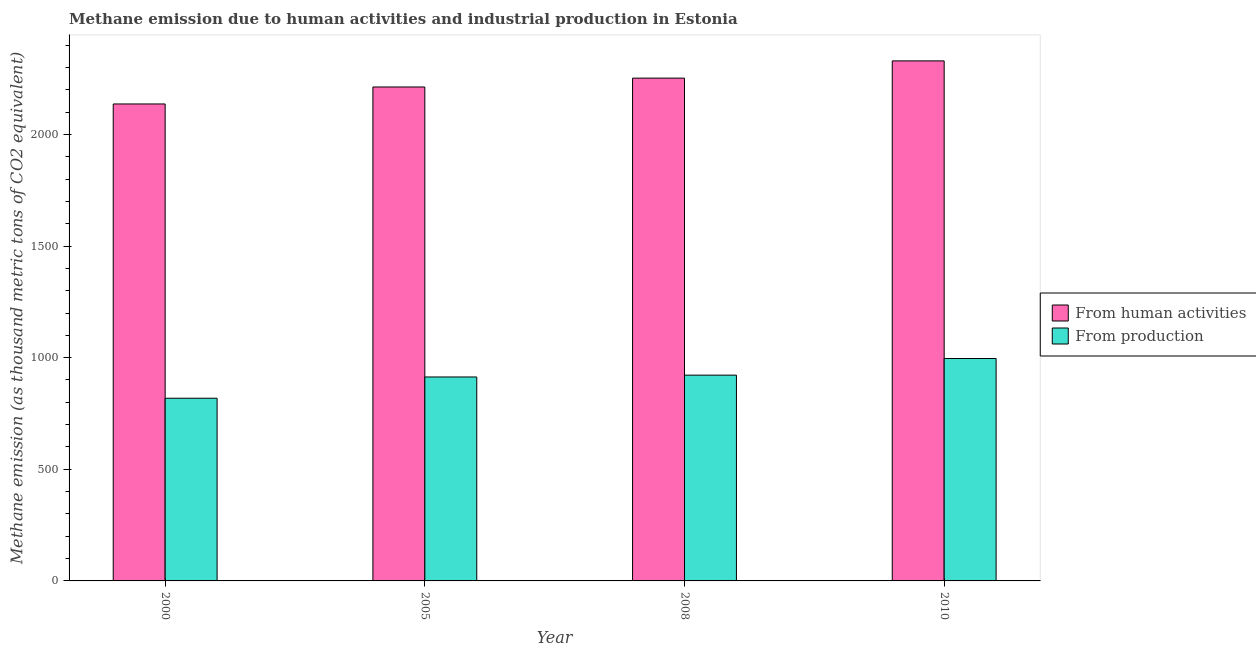How many different coloured bars are there?
Make the answer very short. 2. How many groups of bars are there?
Your response must be concise. 4. Are the number of bars per tick equal to the number of legend labels?
Provide a succinct answer. Yes. Are the number of bars on each tick of the X-axis equal?
Offer a terse response. Yes. How many bars are there on the 4th tick from the left?
Give a very brief answer. 2. How many bars are there on the 1st tick from the right?
Keep it short and to the point. 2. What is the label of the 4th group of bars from the left?
Make the answer very short. 2010. In how many cases, is the number of bars for a given year not equal to the number of legend labels?
Give a very brief answer. 0. What is the amount of emissions generated from industries in 2005?
Offer a terse response. 913.5. Across all years, what is the maximum amount of emissions generated from industries?
Offer a terse response. 996.2. Across all years, what is the minimum amount of emissions generated from industries?
Your response must be concise. 818.2. In which year was the amount of emissions generated from industries minimum?
Your answer should be compact. 2000. What is the total amount of emissions from human activities in the graph?
Ensure brevity in your answer.  8929.9. What is the difference between the amount of emissions generated from industries in 2008 and that in 2010?
Your answer should be compact. -74.5. What is the difference between the amount of emissions generated from industries in 2005 and the amount of emissions from human activities in 2008?
Offer a terse response. -8.2. What is the average amount of emissions from human activities per year?
Ensure brevity in your answer.  2232.48. In the year 2010, what is the difference between the amount of emissions from human activities and amount of emissions generated from industries?
Provide a succinct answer. 0. What is the ratio of the amount of emissions generated from industries in 2000 to that in 2010?
Make the answer very short. 0.82. Is the difference between the amount of emissions generated from industries in 2005 and 2010 greater than the difference between the amount of emissions from human activities in 2005 and 2010?
Your answer should be compact. No. What is the difference between the highest and the second highest amount of emissions from human activities?
Give a very brief answer. 77.3. What is the difference between the highest and the lowest amount of emissions generated from industries?
Make the answer very short. 178. Is the sum of the amount of emissions from human activities in 2000 and 2008 greater than the maximum amount of emissions generated from industries across all years?
Give a very brief answer. Yes. What does the 2nd bar from the left in 2005 represents?
Provide a succinct answer. From production. What does the 1st bar from the right in 2005 represents?
Provide a short and direct response. From production. How many years are there in the graph?
Your answer should be compact. 4. Does the graph contain any zero values?
Your answer should be compact. No. Does the graph contain grids?
Your response must be concise. No. What is the title of the graph?
Make the answer very short. Methane emission due to human activities and industrial production in Estonia. What is the label or title of the X-axis?
Your answer should be very brief. Year. What is the label or title of the Y-axis?
Provide a short and direct response. Methane emission (as thousand metric tons of CO2 equivalent). What is the Methane emission (as thousand metric tons of CO2 equivalent) of From human activities in 2000?
Your answer should be very brief. 2136.3. What is the Methane emission (as thousand metric tons of CO2 equivalent) in From production in 2000?
Provide a short and direct response. 818.2. What is the Methane emission (as thousand metric tons of CO2 equivalent) in From human activities in 2005?
Your answer should be very brief. 2212.3. What is the Methane emission (as thousand metric tons of CO2 equivalent) in From production in 2005?
Your response must be concise. 913.5. What is the Methane emission (as thousand metric tons of CO2 equivalent) in From human activities in 2008?
Your answer should be very brief. 2252. What is the Methane emission (as thousand metric tons of CO2 equivalent) of From production in 2008?
Your response must be concise. 921.7. What is the Methane emission (as thousand metric tons of CO2 equivalent) of From human activities in 2010?
Make the answer very short. 2329.3. What is the Methane emission (as thousand metric tons of CO2 equivalent) in From production in 2010?
Ensure brevity in your answer.  996.2. Across all years, what is the maximum Methane emission (as thousand metric tons of CO2 equivalent) of From human activities?
Make the answer very short. 2329.3. Across all years, what is the maximum Methane emission (as thousand metric tons of CO2 equivalent) in From production?
Your response must be concise. 996.2. Across all years, what is the minimum Methane emission (as thousand metric tons of CO2 equivalent) in From human activities?
Ensure brevity in your answer.  2136.3. Across all years, what is the minimum Methane emission (as thousand metric tons of CO2 equivalent) of From production?
Offer a very short reply. 818.2. What is the total Methane emission (as thousand metric tons of CO2 equivalent) in From human activities in the graph?
Ensure brevity in your answer.  8929.9. What is the total Methane emission (as thousand metric tons of CO2 equivalent) of From production in the graph?
Ensure brevity in your answer.  3649.6. What is the difference between the Methane emission (as thousand metric tons of CO2 equivalent) of From human activities in 2000 and that in 2005?
Ensure brevity in your answer.  -76. What is the difference between the Methane emission (as thousand metric tons of CO2 equivalent) in From production in 2000 and that in 2005?
Provide a succinct answer. -95.3. What is the difference between the Methane emission (as thousand metric tons of CO2 equivalent) of From human activities in 2000 and that in 2008?
Your answer should be compact. -115.7. What is the difference between the Methane emission (as thousand metric tons of CO2 equivalent) in From production in 2000 and that in 2008?
Give a very brief answer. -103.5. What is the difference between the Methane emission (as thousand metric tons of CO2 equivalent) in From human activities in 2000 and that in 2010?
Provide a short and direct response. -193. What is the difference between the Methane emission (as thousand metric tons of CO2 equivalent) of From production in 2000 and that in 2010?
Make the answer very short. -178. What is the difference between the Methane emission (as thousand metric tons of CO2 equivalent) of From human activities in 2005 and that in 2008?
Make the answer very short. -39.7. What is the difference between the Methane emission (as thousand metric tons of CO2 equivalent) of From production in 2005 and that in 2008?
Provide a succinct answer. -8.2. What is the difference between the Methane emission (as thousand metric tons of CO2 equivalent) of From human activities in 2005 and that in 2010?
Ensure brevity in your answer.  -117. What is the difference between the Methane emission (as thousand metric tons of CO2 equivalent) of From production in 2005 and that in 2010?
Provide a short and direct response. -82.7. What is the difference between the Methane emission (as thousand metric tons of CO2 equivalent) in From human activities in 2008 and that in 2010?
Provide a succinct answer. -77.3. What is the difference between the Methane emission (as thousand metric tons of CO2 equivalent) of From production in 2008 and that in 2010?
Make the answer very short. -74.5. What is the difference between the Methane emission (as thousand metric tons of CO2 equivalent) in From human activities in 2000 and the Methane emission (as thousand metric tons of CO2 equivalent) in From production in 2005?
Offer a terse response. 1222.8. What is the difference between the Methane emission (as thousand metric tons of CO2 equivalent) of From human activities in 2000 and the Methane emission (as thousand metric tons of CO2 equivalent) of From production in 2008?
Provide a succinct answer. 1214.6. What is the difference between the Methane emission (as thousand metric tons of CO2 equivalent) in From human activities in 2000 and the Methane emission (as thousand metric tons of CO2 equivalent) in From production in 2010?
Make the answer very short. 1140.1. What is the difference between the Methane emission (as thousand metric tons of CO2 equivalent) in From human activities in 2005 and the Methane emission (as thousand metric tons of CO2 equivalent) in From production in 2008?
Ensure brevity in your answer.  1290.6. What is the difference between the Methane emission (as thousand metric tons of CO2 equivalent) of From human activities in 2005 and the Methane emission (as thousand metric tons of CO2 equivalent) of From production in 2010?
Your response must be concise. 1216.1. What is the difference between the Methane emission (as thousand metric tons of CO2 equivalent) in From human activities in 2008 and the Methane emission (as thousand metric tons of CO2 equivalent) in From production in 2010?
Your answer should be very brief. 1255.8. What is the average Methane emission (as thousand metric tons of CO2 equivalent) of From human activities per year?
Make the answer very short. 2232.47. What is the average Methane emission (as thousand metric tons of CO2 equivalent) in From production per year?
Ensure brevity in your answer.  912.4. In the year 2000, what is the difference between the Methane emission (as thousand metric tons of CO2 equivalent) in From human activities and Methane emission (as thousand metric tons of CO2 equivalent) in From production?
Offer a very short reply. 1318.1. In the year 2005, what is the difference between the Methane emission (as thousand metric tons of CO2 equivalent) of From human activities and Methane emission (as thousand metric tons of CO2 equivalent) of From production?
Ensure brevity in your answer.  1298.8. In the year 2008, what is the difference between the Methane emission (as thousand metric tons of CO2 equivalent) of From human activities and Methane emission (as thousand metric tons of CO2 equivalent) of From production?
Your response must be concise. 1330.3. In the year 2010, what is the difference between the Methane emission (as thousand metric tons of CO2 equivalent) of From human activities and Methane emission (as thousand metric tons of CO2 equivalent) of From production?
Provide a succinct answer. 1333.1. What is the ratio of the Methane emission (as thousand metric tons of CO2 equivalent) in From human activities in 2000 to that in 2005?
Provide a succinct answer. 0.97. What is the ratio of the Methane emission (as thousand metric tons of CO2 equivalent) in From production in 2000 to that in 2005?
Your answer should be compact. 0.9. What is the ratio of the Methane emission (as thousand metric tons of CO2 equivalent) in From human activities in 2000 to that in 2008?
Your response must be concise. 0.95. What is the ratio of the Methane emission (as thousand metric tons of CO2 equivalent) of From production in 2000 to that in 2008?
Your response must be concise. 0.89. What is the ratio of the Methane emission (as thousand metric tons of CO2 equivalent) of From human activities in 2000 to that in 2010?
Provide a short and direct response. 0.92. What is the ratio of the Methane emission (as thousand metric tons of CO2 equivalent) of From production in 2000 to that in 2010?
Your response must be concise. 0.82. What is the ratio of the Methane emission (as thousand metric tons of CO2 equivalent) in From human activities in 2005 to that in 2008?
Provide a short and direct response. 0.98. What is the ratio of the Methane emission (as thousand metric tons of CO2 equivalent) of From human activities in 2005 to that in 2010?
Provide a succinct answer. 0.95. What is the ratio of the Methane emission (as thousand metric tons of CO2 equivalent) in From production in 2005 to that in 2010?
Provide a succinct answer. 0.92. What is the ratio of the Methane emission (as thousand metric tons of CO2 equivalent) of From human activities in 2008 to that in 2010?
Keep it short and to the point. 0.97. What is the ratio of the Methane emission (as thousand metric tons of CO2 equivalent) of From production in 2008 to that in 2010?
Ensure brevity in your answer.  0.93. What is the difference between the highest and the second highest Methane emission (as thousand metric tons of CO2 equivalent) in From human activities?
Your answer should be very brief. 77.3. What is the difference between the highest and the second highest Methane emission (as thousand metric tons of CO2 equivalent) in From production?
Your answer should be very brief. 74.5. What is the difference between the highest and the lowest Methane emission (as thousand metric tons of CO2 equivalent) in From human activities?
Offer a very short reply. 193. What is the difference between the highest and the lowest Methane emission (as thousand metric tons of CO2 equivalent) of From production?
Your answer should be very brief. 178. 